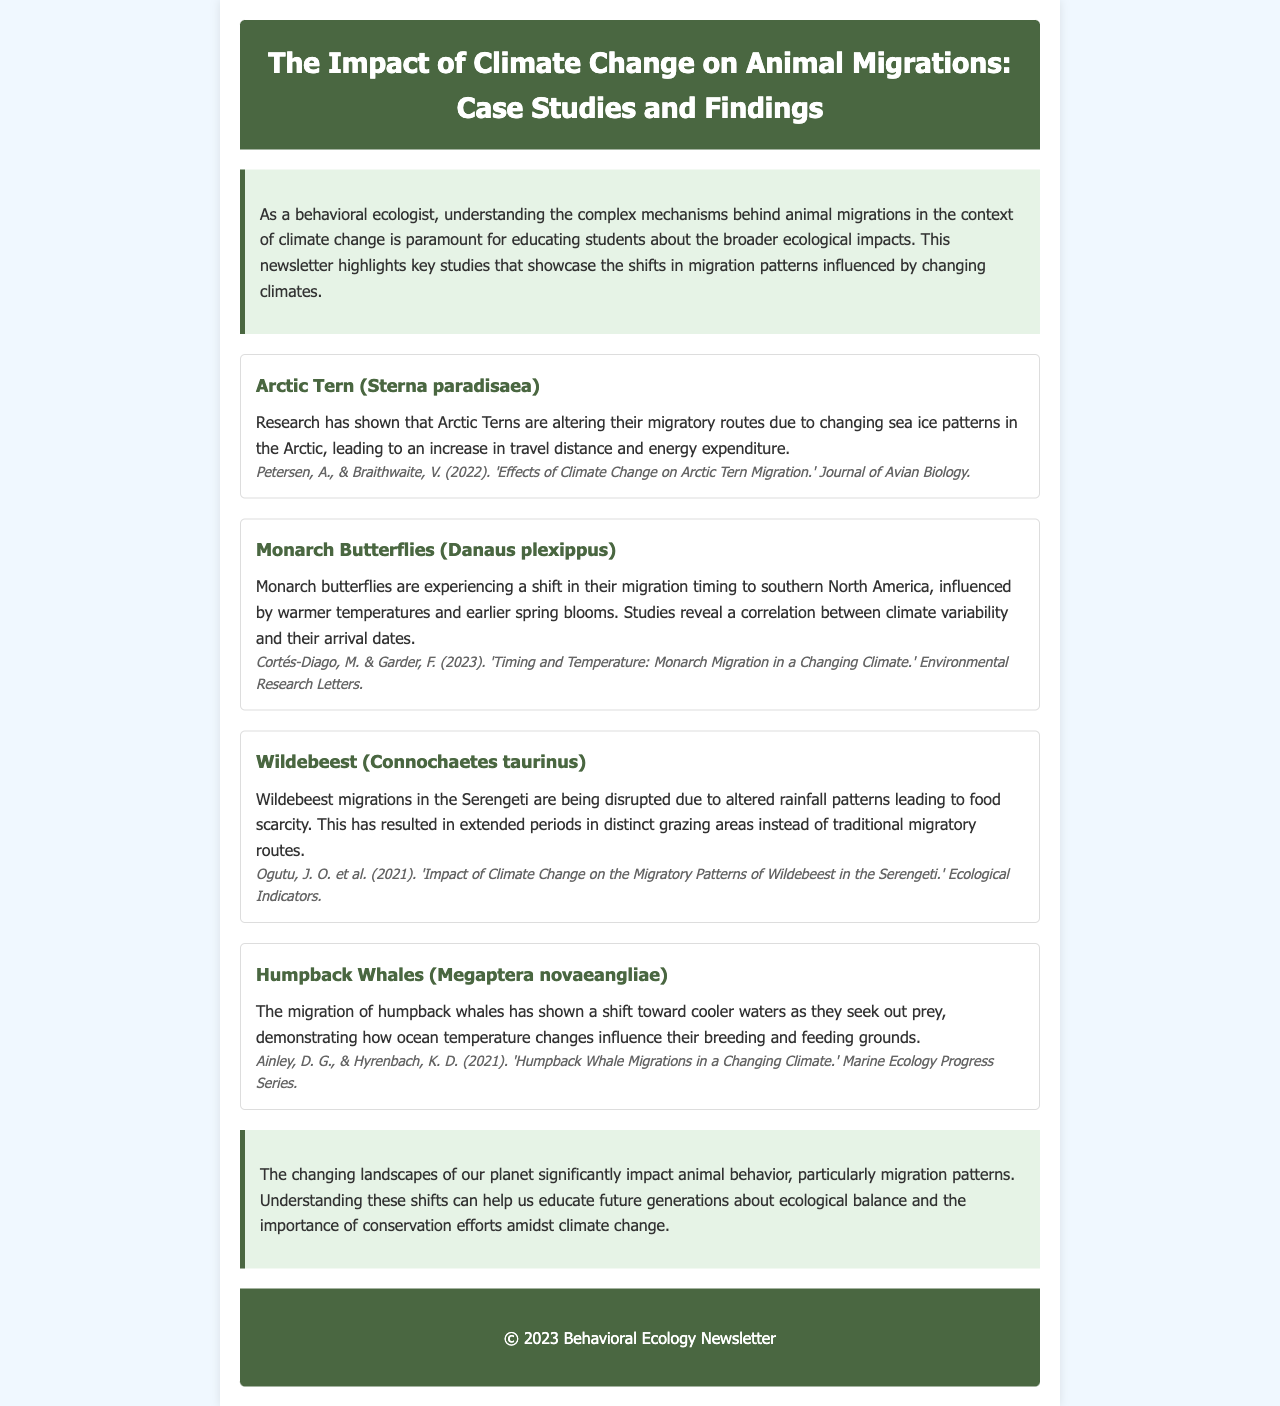What is the title of the newsletter? The title of the newsletter is stated prominently at the top of the document, capturing the overall theme of the content.
Answer: The Impact of Climate Change on Animal Migrations: Case Studies and Findings Which species is associated with the research by Petersen and Braithwaite? The species mentioned alongside the research by Petersen and Braithwaite focuses on the migratory patterns influenced by climate change.
Answer: Arctic Tern (Sterna paradisaea) What does the shift in Monarch Butterflies' migration timing correlate with? The findings indicate a specific factor that influences the Monarch Butterflies' migration timing, which is mentioned in the document.
Answer: Climate variability In what year was the study about Wildebeest migrations published? The document lists the publication year for the study on Wildebeest migrations, which is crucial for understanding temporal relevance.
Answer: 2021 What is a key factor affecting Humpback Whale migrations according to the document? The analysis highlights a significant environmental change affecting Humpback Whale migrations, as described in the case study.
Answer: Ocean temperature changes How has climate change particularly influenced Arctic Tern migration? The document elaborates on the specific changes in migratory routes and travel distance due to environmental shifts.
Answer: Changing sea ice patterns Which case study discusses food scarcity due to altered rainfall patterns? This question seeks to identify the animal species whose migration is disrupted by food availability, as detailed in one of the case studies.
Answer: Wildebeest (Connochaetes taurinus) What is the conclusion regarding animal behavior and migration patterns? The conclusion summarizes the overarching theme in the document about ecological impacts on animal behavior related to climate change.
Answer: The changing landscapes of our planet significantly impact animal behavior 